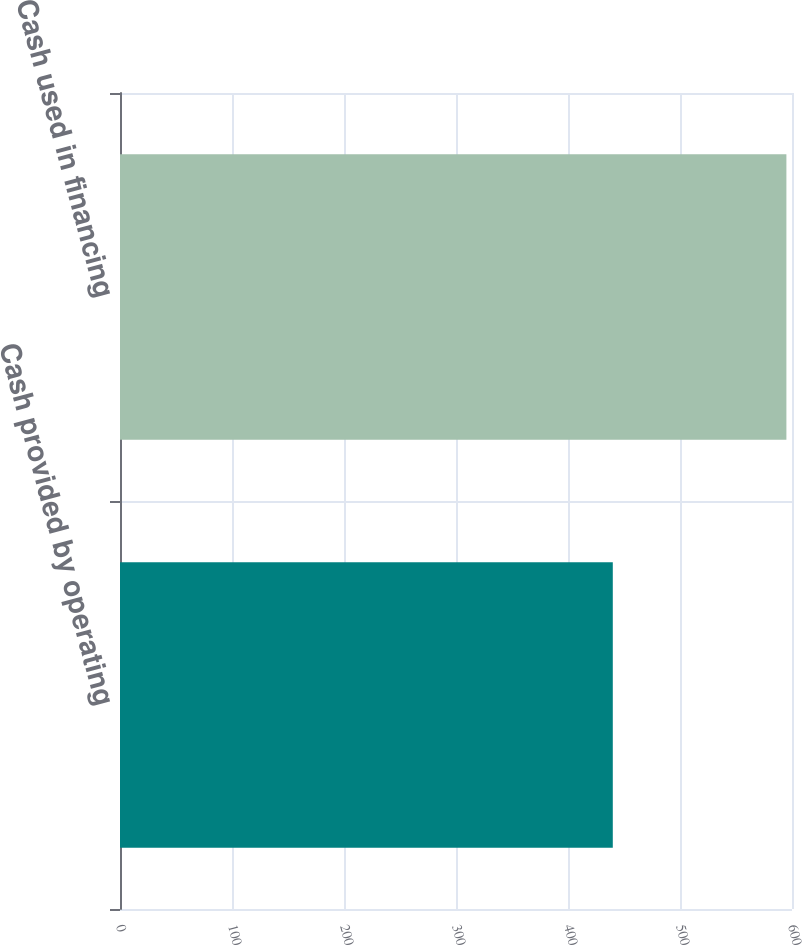<chart> <loc_0><loc_0><loc_500><loc_500><bar_chart><fcel>Cash provided by operating<fcel>Cash used in financing<nl><fcel>440<fcel>595<nl></chart> 